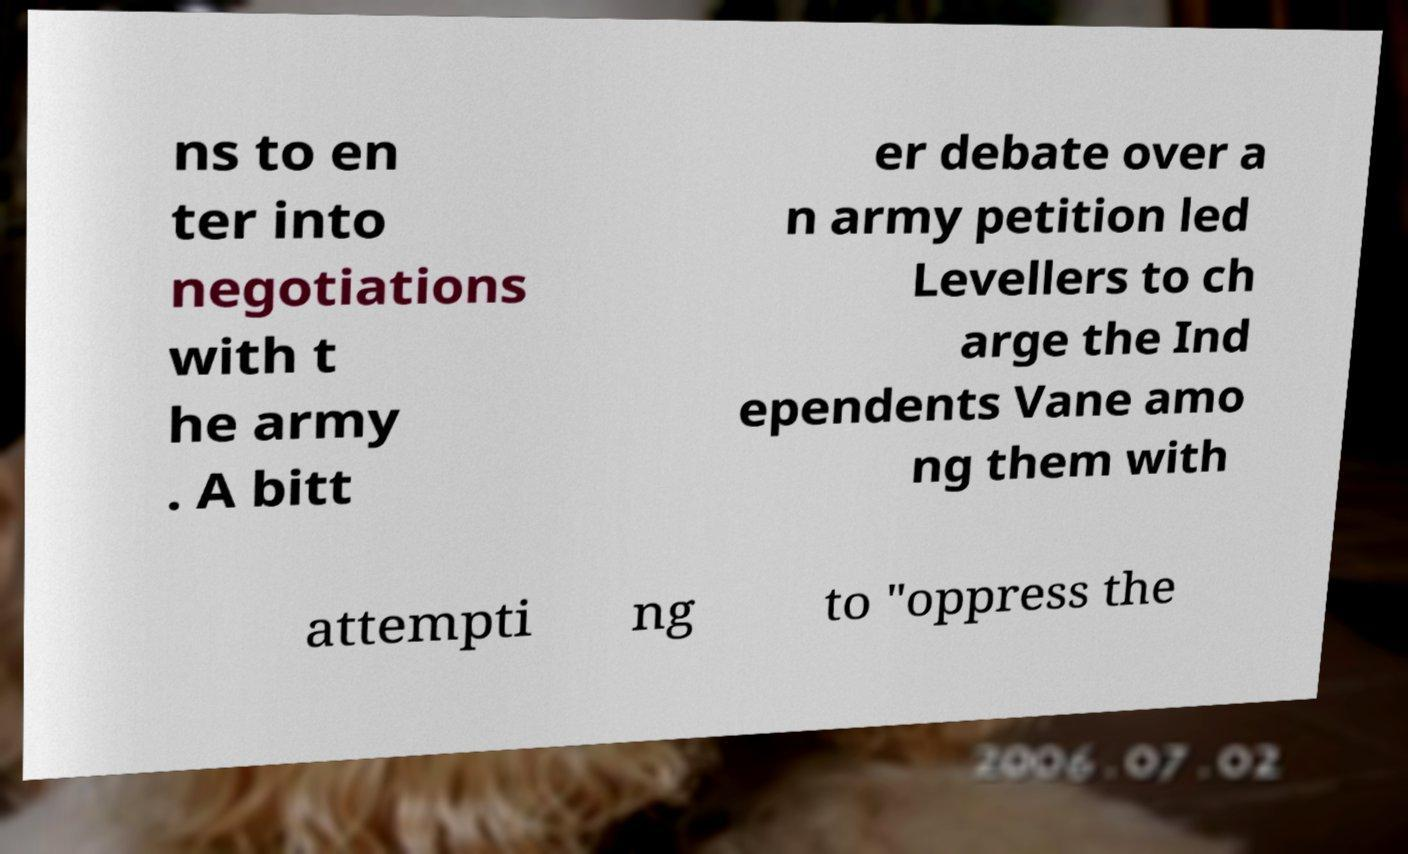Could you assist in decoding the text presented in this image and type it out clearly? ns to en ter into negotiations with t he army . A bitt er debate over a n army petition led Levellers to ch arge the Ind ependents Vane amo ng them with attempti ng to "oppress the 